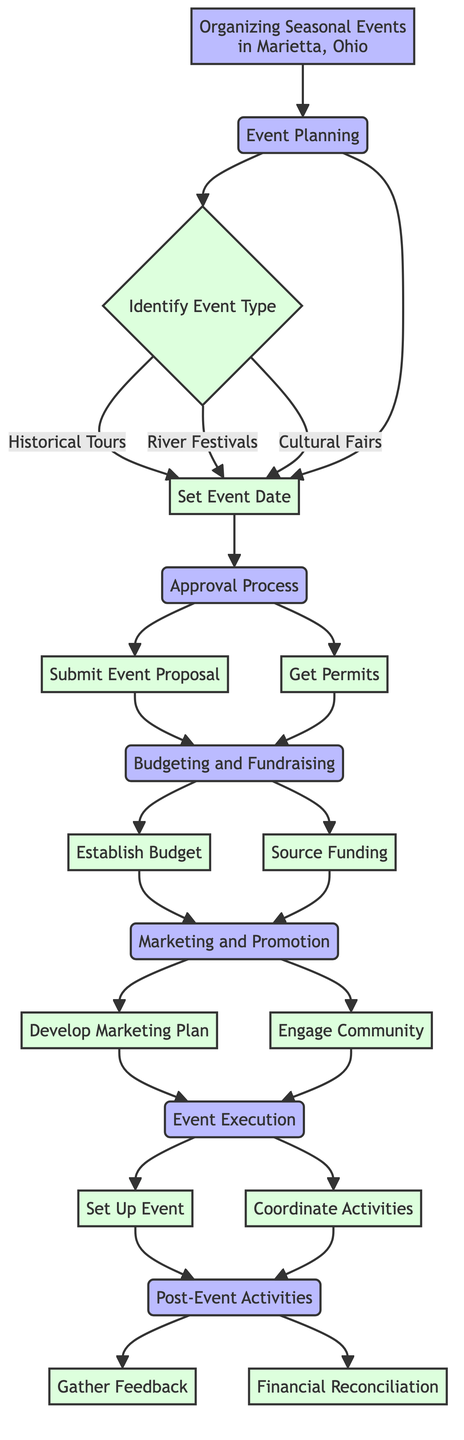What is the first step in organizing events? The first step shown in the diagram is "Event Planning," which is the initial stage of organizing seasonal events.
Answer: Event Planning How many types of events can be identified in the "Identify Event Type" step? There are three types of events listed under the "Identify Event Type" step: Historical Tours, River Festivals, and Cultural Fairs.
Answer: Three What must be submitted in the Approval Process? In the Approval Process, the "Submit Event Proposal" action is required, as indicated in the flow.
Answer: Submit Event Proposal Which step includes both establishing the budget and sourcing funding? The "Budgeting and Fundraising" step includes both "Establish Budget" and "Source Funding" actions.
Answer: Budgeting and Fundraising What connects the "Get Permits" action to the "Budgeting and Fundraising" step? "Get Permits" is connected to the "Budgeting and Fundraising" step by the Approval Process node, which precedes it.
Answer: Approval Process What are two tasks involved in the Event Execution stage? The two tasks mentioned in the Event Execution stage are "Set Up Event" and "Coordinate Activities."
Answer: Set Up Event, Coordinate Activities Which step follows the "Marketing and Promotion" phase? The diagram indicates that "Event Execution" follows the "Marketing and Promotion" phase.
Answer: Event Execution What is the final activity listed after the event has been executed? The final activity listed after execution is "Post-Event Activities," which logically follows after events have taken place.
Answer: Post-Event Activities How are community groups engaged according to the Marketing and Promotion step? Community groups are engaged in the Marketing and Promotion step through the action "Engage Community."
Answer: Engage Community What must be done to review expenses after an event? To review expenses after an event, the action defined in the Post-Event Activities is "Financial Reconciliation."
Answer: Financial Reconciliation 